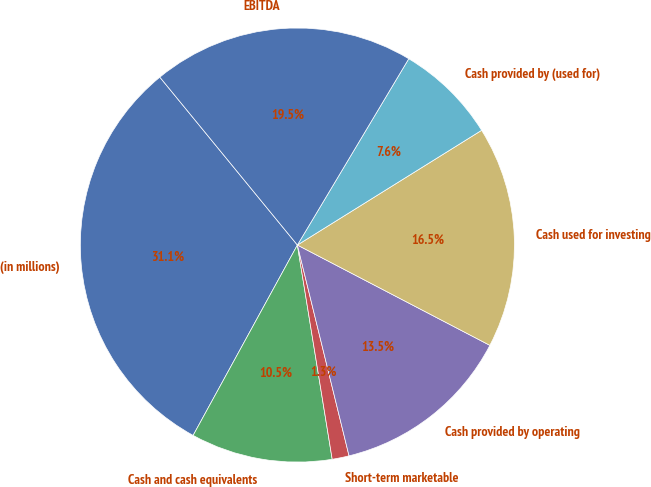Convert chart to OTSL. <chart><loc_0><loc_0><loc_500><loc_500><pie_chart><fcel>(in millions)<fcel>Cash and cash equivalents<fcel>Short-term marketable<fcel>Cash provided by operating<fcel>Cash used for investing<fcel>Cash provided by (used for)<fcel>EBITDA<nl><fcel>31.1%<fcel>10.54%<fcel>1.26%<fcel>13.53%<fcel>16.51%<fcel>7.56%<fcel>19.5%<nl></chart> 